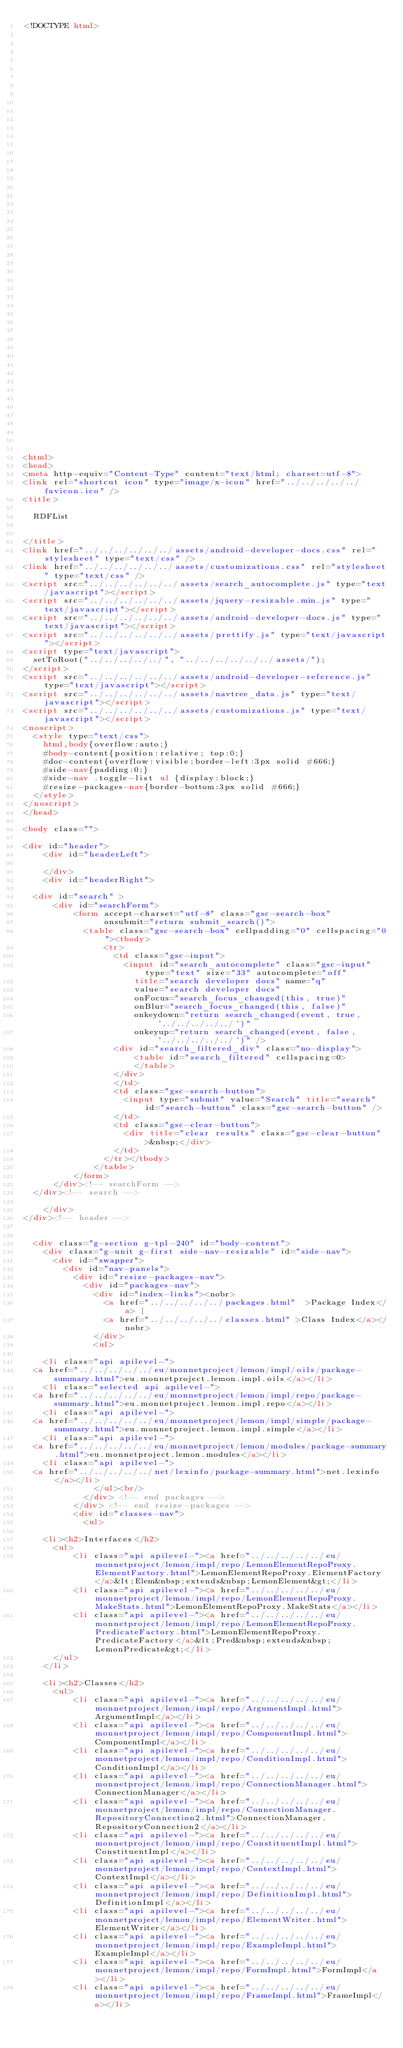Convert code to text. <code><loc_0><loc_0><loc_500><loc_500><_HTML_><!DOCTYPE html>


















































<html>
<head>
<meta http-equiv="Content-Type" content="text/html; charset=utf-8">
<link rel="shortcut icon" type="image/x-icon" href="../../../../../favicon.ico" />
<title>

  RDFList


</title>
<link href="../../../../../../assets/android-developer-docs.css" rel="stylesheet" type="text/css" />
<link href="../../../../../../assets/customizations.css" rel="stylesheet" type="text/css" />
<script src="../../../../../../assets/search_autocomplete.js" type="text/javascript"></script>
<script src="../../../../../../assets/jquery-resizable.min.js" type="text/javascript"></script>
<script src="../../../../../../assets/android-developer-docs.js" type="text/javascript"></script>
<script src="../../../../../../assets/prettify.js" type="text/javascript"></script>
<script type="text/javascript">
  setToRoot("../../../../../", "../../../../../../assets/");
</script>
<script src="../../../../../../assets/android-developer-reference.js" type="text/javascript"></script>
<script src="../../../../../../assets/navtree_data.js" type="text/javascript"></script>
<script src="../../../../../../assets/customizations.js" type="text/javascript"></script>
<noscript>
  <style type="text/css">
    html,body{overflow:auto;}
    #body-content{position:relative; top:0;}
    #doc-content{overflow:visible;border-left:3px solid #666;}
    #side-nav{padding:0;}
    #side-nav .toggle-list ul {display:block;}
    #resize-packages-nav{border-bottom:3px solid #666;}
  </style>
</noscript>
</head>

<body class="">

<div id="header">
    <div id="headerLeft">
    
    </div>
    <div id="headerRight">
      
  <div id="search" >
      <div id="searchForm">
          <form accept-charset="utf-8" class="gsc-search-box" 
                onsubmit="return submit_search()">
            <table class="gsc-search-box" cellpadding="0" cellspacing="0"><tbody>
                <tr>
                  <td class="gsc-input">
                    <input id="search_autocomplete" class="gsc-input" type="text" size="33" autocomplete="off"
                      title="search developer docs" name="q"
                      value="search developer docs"
                      onFocus="search_focus_changed(this, true)"
                      onBlur="search_focus_changed(this, false)"
                      onkeydown="return search_changed(event, true, '../../../../../')"
                      onkeyup="return search_changed(event, false, '../../../../../')" />
                  <div id="search_filtered_div" class="no-display">
                      <table id="search_filtered" cellspacing=0>
                      </table>
                  </div>
                  </td>
                  <td class="gsc-search-button">
                    <input type="submit" value="Search" title="search" id="search-button" class="gsc-search-button" />
                  </td>
                  <td class="gsc-clear-button">
                    <div title="clear results" class="gsc-clear-button">&nbsp;</div>
                  </td>
                </tr></tbody>
              </table>
          </form>
      </div><!-- searchForm -->
  </div><!-- search -->
      
    </div>
</div><!-- header -->


  <div class="g-section g-tpl-240" id="body-content">
    <div class="g-unit g-first side-nav-resizable" id="side-nav">
      <div id="swapper">
        <div id="nav-panels">
          <div id="resize-packages-nav">
            <div id="packages-nav">
              <div id="index-links"><nobr>
                <a href="../../../../../packages.html"  >Package Index</a> | 
                <a href="../../../../../classes.html" >Class Index</a></nobr>
              </div>
              <ul>
                
    <li class="api apilevel-">
  <a href="../../../../../eu/monnetproject/lemon/impl/oils/package-summary.html">eu.monnetproject.lemon.impl.oils</a></li>
    <li class="selected api apilevel-">
  <a href="../../../../../eu/monnetproject/lemon/impl/repo/package-summary.html">eu.monnetproject.lemon.impl.repo</a></li>
    <li class="api apilevel-">
  <a href="../../../../../eu/monnetproject/lemon/impl/simple/package-summary.html">eu.monnetproject.lemon.impl.simple</a></li>
    <li class="api apilevel-">
  <a href="../../../../../eu/monnetproject/lemon/modules/package-summary.html">eu.monnetproject.lemon.modules</a></li>
    <li class="api apilevel-">
  <a href="../../../../../net/lexinfo/package-summary.html">net.lexinfo</a></li>
              </ul><br/>
            </div> <!-- end packages -->
          </div> <!-- end resize-packages -->
          <div id="classes-nav">
            <ul>
              
    <li><h2>Interfaces</h2>
      <ul>
          <li class="api apilevel-"><a href="../../../../../eu/monnetproject/lemon/impl/repo/LemonElementRepoProxy.ElementFactory.html">LemonElementRepoProxy.ElementFactory</a>&lt;Elem&nbsp;extends&nbsp;LemonElement&gt;</li>
          <li class="api apilevel-"><a href="../../../../../eu/monnetproject/lemon/impl/repo/LemonElementRepoProxy.MakeStats.html">LemonElementRepoProxy.MakeStats</a></li>
          <li class="api apilevel-"><a href="../../../../../eu/monnetproject/lemon/impl/repo/LemonElementRepoProxy.PredicateFactory.html">LemonElementRepoProxy.PredicateFactory</a>&lt;Pred&nbsp;extends&nbsp;LemonPredicate&gt;</li>
      </ul>
    </li>
              
    <li><h2>Classes</h2>
      <ul>
          <li class="api apilevel-"><a href="../../../../../eu/monnetproject/lemon/impl/repo/ArgumentImpl.html">ArgumentImpl</a></li>
          <li class="api apilevel-"><a href="../../../../../eu/monnetproject/lemon/impl/repo/ComponentImpl.html">ComponentImpl</a></li>
          <li class="api apilevel-"><a href="../../../../../eu/monnetproject/lemon/impl/repo/ConditionImpl.html">ConditionImpl</a></li>
          <li class="api apilevel-"><a href="../../../../../eu/monnetproject/lemon/impl/repo/ConnectionManager.html">ConnectionManager</a></li>
          <li class="api apilevel-"><a href="../../../../../eu/monnetproject/lemon/impl/repo/ConnectionManager.RepositoryConnection2.html">ConnectionManager.RepositoryConnection2</a></li>
          <li class="api apilevel-"><a href="../../../../../eu/monnetproject/lemon/impl/repo/ConstituentImpl.html">ConstituentImpl</a></li>
          <li class="api apilevel-"><a href="../../../../../eu/monnetproject/lemon/impl/repo/ContextImpl.html">ContextImpl</a></li>
          <li class="api apilevel-"><a href="../../../../../eu/monnetproject/lemon/impl/repo/DefinitionImpl.html">DefinitionImpl</a></li>
          <li class="api apilevel-"><a href="../../../../../eu/monnetproject/lemon/impl/repo/ElementWriter.html">ElementWriter</a></li>
          <li class="api apilevel-"><a href="../../../../../eu/monnetproject/lemon/impl/repo/ExampleImpl.html">ExampleImpl</a></li>
          <li class="api apilevel-"><a href="../../../../../eu/monnetproject/lemon/impl/repo/FormImpl.html">FormImpl</a></li>
          <li class="api apilevel-"><a href="../../../../../eu/monnetproject/lemon/impl/repo/FrameImpl.html">FrameImpl</a></li></code> 